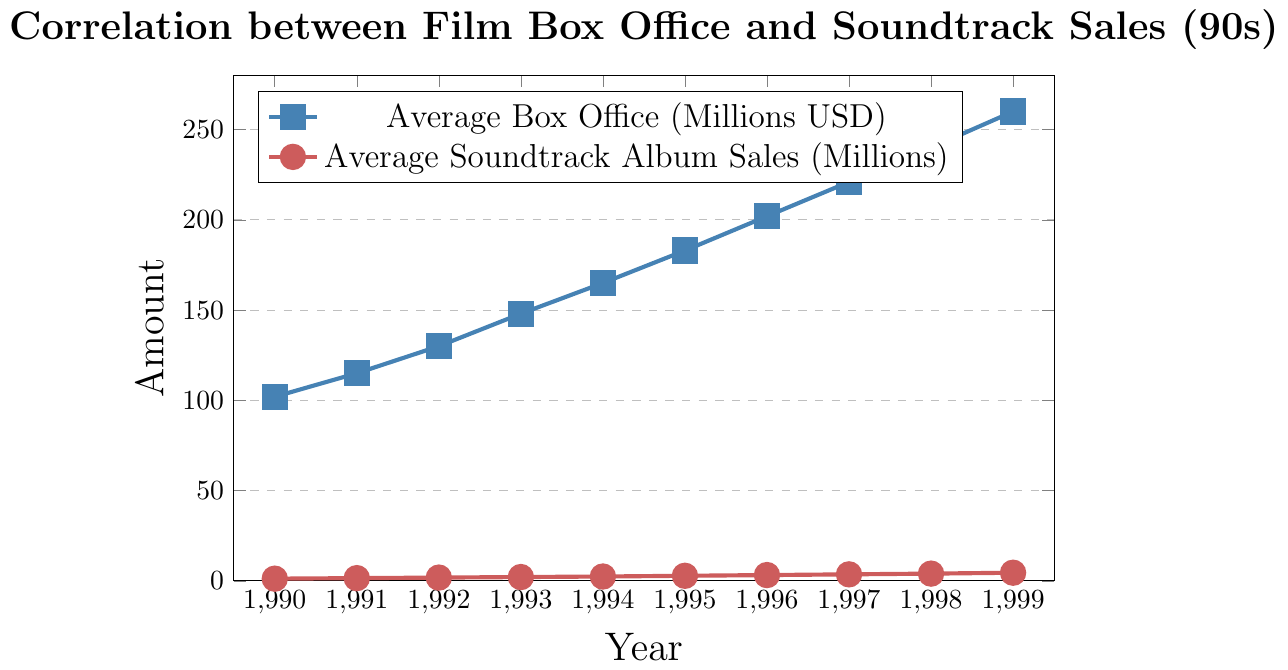How much did the average box office earnings increase from 1990 to 1999? To determine the increase, subtract the box office earnings in 1990 from those in 1999: 260 - 102.
Answer: 158 million USD Do the average box office earnings and average soundtrack album sales follow a similar trend over the years? By observing the visual representation, both lines show a consistent and steady increase from 1990 to 1999, suggesting a similar upward trend.
Answer: Yes In which year did the average box office earnings surpass 200 million USD? Identify the first year on the x-axis where the blue line crosses the 200 million USD mark on the y-axis. This occurs in 1996.
Answer: 1996 What is the average growth rate per year for soundtrack album sales between 1990 and 1999? Subtract the starting value (1.2 million in 1990) from the ending value (4.5 million in 1999), then divide by the number of years (9): (4.5 - 1.2)/9.
Answer: 0.367 million USD/year Compare the box office earnings and soundtrack sales in 1995. Which one shows a higher percent increase compared to the previous year? To calculate the box office earnings increase, ((183 - 165) / 165) * 100 ≈ 10.91%. To calculate the soundtrack sales increase, ((2.8 - 2.4) / 2.4) * 100 ≈ 16.67%. Soundtrack sales show a higher percent increase.
Answer: Soundtrack sales By how much did the soundtrack album sales increase from 1994 to 1998? Subtract the soundtrack album sales in 1994 from those in 1998: 4.0 - 2.4.
Answer: 1.6 million USD Which year saw the highest average box office earnings, and what was the figure? Scan for the maximum value along the blue line and identify the corresponding year on the x-axis. The highest earnings were in 1999 at 260 million USD.
Answer: 1999, 260 million USD Is there any year where the average soundtrack album sales decreased compared to the previous year? Observe the red line and ensure it consistently increases without any downward slope relative to the previous year. There is no such decrease from 1990 to 1999.
Answer: No How much did both the average box office earnings and soundtrack album sales increase in 1993 compared to 1992? For box office earnings: 148 - 130 = 18 million USD. For soundtrack sales: 2.1 - 1.8 = 0.3 million USD.
Answer: 18 million USD and 0.3 million USD 